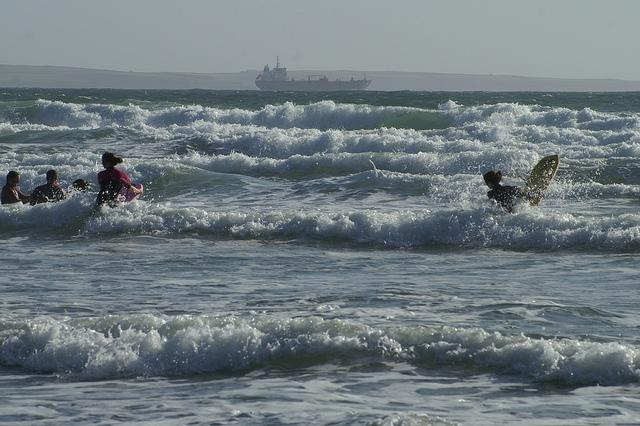What activity is taking place besides surfing? Please explain your reasoning. swimming. There are people in the water that are swimming and aren't using any equipment. 